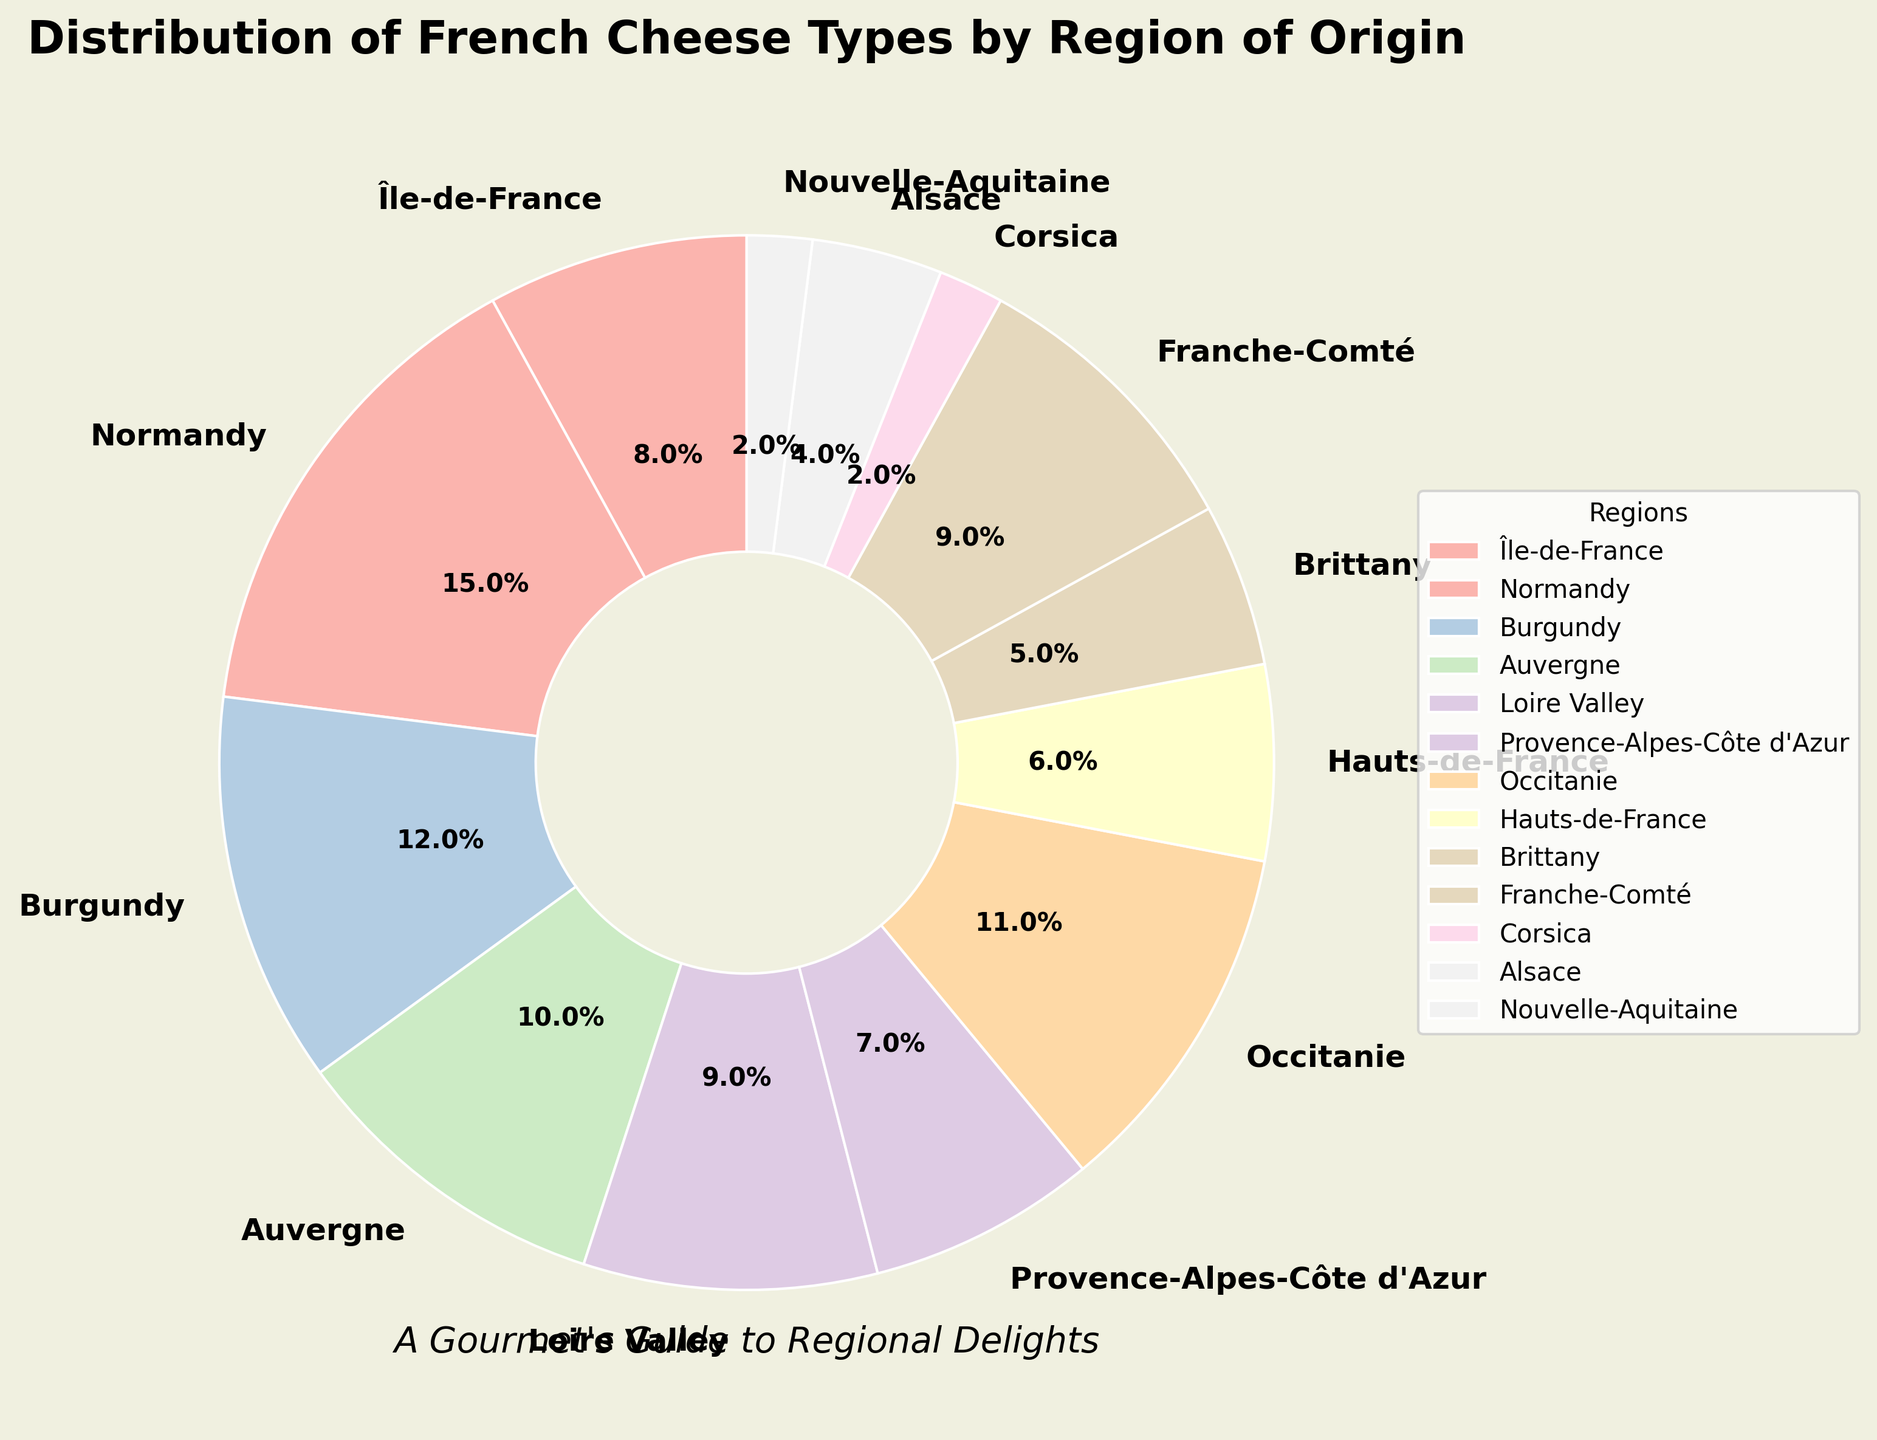Which region contributes the smallest percentage of French cheese types? Look for the segment with the smallest percentage. Corsica and Nouvelle-Aquitaine both have the smallest share at 2%.
Answer: Corsica, Nouvelle-Aquitaine Which two regions collectively contribute more than 20% of French cheese types? Add the percentages of various regions and check which pairs exceed 20%. Normandy (15%) and Île-de-France (8%) together exceed 20%.
Answer: Normandy, Île-de-France How does the percentage of cheese types from Provence-Alpes-Côte d'Azur compare with those from Brittany? Compare the values. Provence-Alpes-Côte d'Azur is 7% and Brittany is 5%. Provence-Alpes-Côte d'Azur has a higher percentage.
Answer: Provence-Alpes-Côte d'Azur has a higher percentage How many regions contribute at least 10% to the total cheese types? Count the regions with percentages of 10 or more. Normandy, Burgundy, Auvergne, and Occitanie meet this criterion.
Answer: 4 regions What is the difference in contribution between Normandy and Hauts-de-France? Subtract the percentage of Hauts-de-France from Normandy's. Normandy (15%) minus Hauts-de-France (6%) is 9%.
Answer: 9% Which region is represented by a wedge with a 6% contribution? Identify the region corresponding to the 6% value. It is Hauts-de-France.
Answer: Hauts-de-France If Île-de-France’s contribution were increased by 2%, which region would have an equivalent contribution? Add 2% to Île-de-France's 8% to get 10%, which matches Auvergne’s contribution.
Answer: Auvergne What is the combined contribution of Île-de-France, Auvergne, and Franche-Comté? Sum the percentages of the three regions: 8% (Île-de-France) + 10% (Auvergne) + 9% (Franche-Comté) = 27%.
Answer: 27% How does Alsace’s contribution compare to Nouvelle-Aquitaine's? Compare the values. Alsace is 4% and Nouvelle-Aquitaine is 2%. Alsace has a higher percentage.
Answer: Alsace has a higher percentage Which region’s contribution is visually represented right next to Normandy's segment in the pie chart? Visually identify the segment adjacent to Normandy (15%). Île-de-France (8%) is next to it.
Answer: Île-de-France 